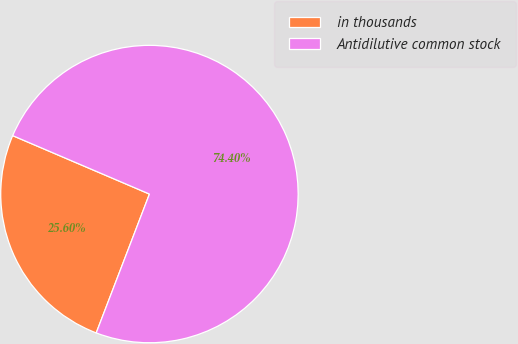<chart> <loc_0><loc_0><loc_500><loc_500><pie_chart><fcel>in thousands<fcel>Antidilutive common stock<nl><fcel>25.6%<fcel>74.4%<nl></chart> 